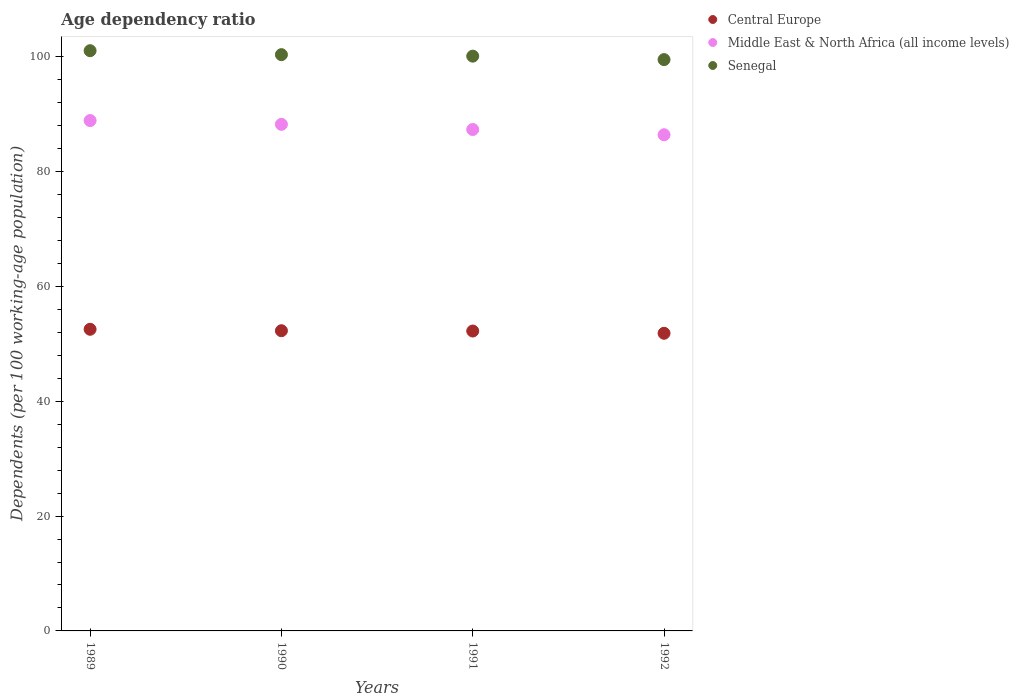What is the age dependency ratio in in Middle East & North Africa (all income levels) in 1991?
Make the answer very short. 87.33. Across all years, what is the maximum age dependency ratio in in Senegal?
Give a very brief answer. 101.06. Across all years, what is the minimum age dependency ratio in in Middle East & North Africa (all income levels)?
Offer a very short reply. 86.42. In which year was the age dependency ratio in in Central Europe maximum?
Make the answer very short. 1989. In which year was the age dependency ratio in in Central Europe minimum?
Your answer should be very brief. 1992. What is the total age dependency ratio in in Senegal in the graph?
Make the answer very short. 401.05. What is the difference between the age dependency ratio in in Middle East & North Africa (all income levels) in 1989 and that in 1991?
Keep it short and to the point. 1.56. What is the difference between the age dependency ratio in in Senegal in 1991 and the age dependency ratio in in Central Europe in 1992?
Your response must be concise. 48.27. What is the average age dependency ratio in in Senegal per year?
Make the answer very short. 100.26. In the year 1992, what is the difference between the age dependency ratio in in Senegal and age dependency ratio in in Middle East & North Africa (all income levels)?
Provide a succinct answer. 13.09. What is the ratio of the age dependency ratio in in Middle East & North Africa (all income levels) in 1990 to that in 1991?
Offer a terse response. 1.01. Is the difference between the age dependency ratio in in Senegal in 1989 and 1990 greater than the difference between the age dependency ratio in in Middle East & North Africa (all income levels) in 1989 and 1990?
Ensure brevity in your answer.  Yes. What is the difference between the highest and the second highest age dependency ratio in in Senegal?
Keep it short and to the point. 0.69. What is the difference between the highest and the lowest age dependency ratio in in Central Europe?
Offer a terse response. 0.7. In how many years, is the age dependency ratio in in Central Europe greater than the average age dependency ratio in in Central Europe taken over all years?
Provide a succinct answer. 3. Is the sum of the age dependency ratio in in Middle East & North Africa (all income levels) in 1989 and 1990 greater than the maximum age dependency ratio in in Central Europe across all years?
Offer a terse response. Yes. Is it the case that in every year, the sum of the age dependency ratio in in Middle East & North Africa (all income levels) and age dependency ratio in in Senegal  is greater than the age dependency ratio in in Central Europe?
Offer a terse response. Yes. Is the age dependency ratio in in Senegal strictly greater than the age dependency ratio in in Central Europe over the years?
Ensure brevity in your answer.  Yes. How many years are there in the graph?
Give a very brief answer. 4. Are the values on the major ticks of Y-axis written in scientific E-notation?
Ensure brevity in your answer.  No. Does the graph contain grids?
Provide a succinct answer. No. Where does the legend appear in the graph?
Your answer should be very brief. Top right. How many legend labels are there?
Your answer should be very brief. 3. How are the legend labels stacked?
Provide a short and direct response. Vertical. What is the title of the graph?
Ensure brevity in your answer.  Age dependency ratio. Does "Sri Lanka" appear as one of the legend labels in the graph?
Provide a short and direct response. No. What is the label or title of the Y-axis?
Your answer should be compact. Dependents (per 100 working-age population). What is the Dependents (per 100 working-age population) in Central Europe in 1989?
Offer a terse response. 52.54. What is the Dependents (per 100 working-age population) in Middle East & North Africa (all income levels) in 1989?
Make the answer very short. 88.89. What is the Dependents (per 100 working-age population) of Senegal in 1989?
Offer a terse response. 101.06. What is the Dependents (per 100 working-age population) of Central Europe in 1990?
Your answer should be very brief. 52.29. What is the Dependents (per 100 working-age population) in Middle East & North Africa (all income levels) in 1990?
Ensure brevity in your answer.  88.23. What is the Dependents (per 100 working-age population) of Senegal in 1990?
Your answer should be compact. 100.37. What is the Dependents (per 100 working-age population) in Central Europe in 1991?
Offer a very short reply. 52.24. What is the Dependents (per 100 working-age population) of Middle East & North Africa (all income levels) in 1991?
Offer a terse response. 87.33. What is the Dependents (per 100 working-age population) in Senegal in 1991?
Make the answer very short. 100.11. What is the Dependents (per 100 working-age population) of Central Europe in 1992?
Offer a very short reply. 51.84. What is the Dependents (per 100 working-age population) of Middle East & North Africa (all income levels) in 1992?
Your answer should be very brief. 86.42. What is the Dependents (per 100 working-age population) of Senegal in 1992?
Offer a very short reply. 99.51. Across all years, what is the maximum Dependents (per 100 working-age population) in Central Europe?
Give a very brief answer. 52.54. Across all years, what is the maximum Dependents (per 100 working-age population) of Middle East & North Africa (all income levels)?
Your answer should be very brief. 88.89. Across all years, what is the maximum Dependents (per 100 working-age population) in Senegal?
Your response must be concise. 101.06. Across all years, what is the minimum Dependents (per 100 working-age population) of Central Europe?
Provide a succinct answer. 51.84. Across all years, what is the minimum Dependents (per 100 working-age population) of Middle East & North Africa (all income levels)?
Offer a terse response. 86.42. Across all years, what is the minimum Dependents (per 100 working-age population) in Senegal?
Provide a short and direct response. 99.51. What is the total Dependents (per 100 working-age population) in Central Europe in the graph?
Make the answer very short. 208.91. What is the total Dependents (per 100 working-age population) of Middle East & North Africa (all income levels) in the graph?
Your answer should be compact. 350.88. What is the total Dependents (per 100 working-age population) in Senegal in the graph?
Keep it short and to the point. 401.05. What is the difference between the Dependents (per 100 working-age population) in Central Europe in 1989 and that in 1990?
Provide a succinct answer. 0.25. What is the difference between the Dependents (per 100 working-age population) of Middle East & North Africa (all income levels) in 1989 and that in 1990?
Give a very brief answer. 0.66. What is the difference between the Dependents (per 100 working-age population) in Senegal in 1989 and that in 1990?
Provide a succinct answer. 0.69. What is the difference between the Dependents (per 100 working-age population) in Central Europe in 1989 and that in 1991?
Keep it short and to the point. 0.3. What is the difference between the Dependents (per 100 working-age population) in Middle East & North Africa (all income levels) in 1989 and that in 1991?
Your answer should be very brief. 1.56. What is the difference between the Dependents (per 100 working-age population) in Senegal in 1989 and that in 1991?
Ensure brevity in your answer.  0.95. What is the difference between the Dependents (per 100 working-age population) in Central Europe in 1989 and that in 1992?
Give a very brief answer. 0.7. What is the difference between the Dependents (per 100 working-age population) of Middle East & North Africa (all income levels) in 1989 and that in 1992?
Give a very brief answer. 2.47. What is the difference between the Dependents (per 100 working-age population) in Senegal in 1989 and that in 1992?
Provide a succinct answer. 1.55. What is the difference between the Dependents (per 100 working-age population) in Central Europe in 1990 and that in 1991?
Keep it short and to the point. 0.05. What is the difference between the Dependents (per 100 working-age population) of Middle East & North Africa (all income levels) in 1990 and that in 1991?
Your answer should be compact. 0.9. What is the difference between the Dependents (per 100 working-age population) in Senegal in 1990 and that in 1991?
Keep it short and to the point. 0.26. What is the difference between the Dependents (per 100 working-age population) of Central Europe in 1990 and that in 1992?
Your response must be concise. 0.44. What is the difference between the Dependents (per 100 working-age population) of Middle East & North Africa (all income levels) in 1990 and that in 1992?
Make the answer very short. 1.81. What is the difference between the Dependents (per 100 working-age population) in Senegal in 1990 and that in 1992?
Provide a short and direct response. 0.86. What is the difference between the Dependents (per 100 working-age population) of Central Europe in 1991 and that in 1992?
Keep it short and to the point. 0.39. What is the difference between the Dependents (per 100 working-age population) in Middle East & North Africa (all income levels) in 1991 and that in 1992?
Provide a succinct answer. 0.91. What is the difference between the Dependents (per 100 working-age population) of Senegal in 1991 and that in 1992?
Your answer should be compact. 0.6. What is the difference between the Dependents (per 100 working-age population) of Central Europe in 1989 and the Dependents (per 100 working-age population) of Middle East & North Africa (all income levels) in 1990?
Your answer should be compact. -35.69. What is the difference between the Dependents (per 100 working-age population) of Central Europe in 1989 and the Dependents (per 100 working-age population) of Senegal in 1990?
Give a very brief answer. -47.83. What is the difference between the Dependents (per 100 working-age population) of Middle East & North Africa (all income levels) in 1989 and the Dependents (per 100 working-age population) of Senegal in 1990?
Provide a succinct answer. -11.48. What is the difference between the Dependents (per 100 working-age population) in Central Europe in 1989 and the Dependents (per 100 working-age population) in Middle East & North Africa (all income levels) in 1991?
Offer a very short reply. -34.79. What is the difference between the Dependents (per 100 working-age population) in Central Europe in 1989 and the Dependents (per 100 working-age population) in Senegal in 1991?
Make the answer very short. -47.57. What is the difference between the Dependents (per 100 working-age population) in Middle East & North Africa (all income levels) in 1989 and the Dependents (per 100 working-age population) in Senegal in 1991?
Keep it short and to the point. -11.22. What is the difference between the Dependents (per 100 working-age population) of Central Europe in 1989 and the Dependents (per 100 working-age population) of Middle East & North Africa (all income levels) in 1992?
Ensure brevity in your answer.  -33.88. What is the difference between the Dependents (per 100 working-age population) of Central Europe in 1989 and the Dependents (per 100 working-age population) of Senegal in 1992?
Offer a very short reply. -46.97. What is the difference between the Dependents (per 100 working-age population) of Middle East & North Africa (all income levels) in 1989 and the Dependents (per 100 working-age population) of Senegal in 1992?
Your answer should be compact. -10.62. What is the difference between the Dependents (per 100 working-age population) of Central Europe in 1990 and the Dependents (per 100 working-age population) of Middle East & North Africa (all income levels) in 1991?
Offer a terse response. -35.05. What is the difference between the Dependents (per 100 working-age population) of Central Europe in 1990 and the Dependents (per 100 working-age population) of Senegal in 1991?
Offer a terse response. -47.82. What is the difference between the Dependents (per 100 working-age population) of Middle East & North Africa (all income levels) in 1990 and the Dependents (per 100 working-age population) of Senegal in 1991?
Your answer should be very brief. -11.88. What is the difference between the Dependents (per 100 working-age population) of Central Europe in 1990 and the Dependents (per 100 working-age population) of Middle East & North Africa (all income levels) in 1992?
Make the answer very short. -34.13. What is the difference between the Dependents (per 100 working-age population) in Central Europe in 1990 and the Dependents (per 100 working-age population) in Senegal in 1992?
Ensure brevity in your answer.  -47.22. What is the difference between the Dependents (per 100 working-age population) of Middle East & North Africa (all income levels) in 1990 and the Dependents (per 100 working-age population) of Senegal in 1992?
Your answer should be very brief. -11.28. What is the difference between the Dependents (per 100 working-age population) of Central Europe in 1991 and the Dependents (per 100 working-age population) of Middle East & North Africa (all income levels) in 1992?
Provide a short and direct response. -34.19. What is the difference between the Dependents (per 100 working-age population) of Central Europe in 1991 and the Dependents (per 100 working-age population) of Senegal in 1992?
Keep it short and to the point. -47.27. What is the difference between the Dependents (per 100 working-age population) in Middle East & North Africa (all income levels) in 1991 and the Dependents (per 100 working-age population) in Senegal in 1992?
Offer a terse response. -12.18. What is the average Dependents (per 100 working-age population) of Central Europe per year?
Your response must be concise. 52.23. What is the average Dependents (per 100 working-age population) in Middle East & North Africa (all income levels) per year?
Make the answer very short. 87.72. What is the average Dependents (per 100 working-age population) of Senegal per year?
Your answer should be very brief. 100.26. In the year 1989, what is the difference between the Dependents (per 100 working-age population) in Central Europe and Dependents (per 100 working-age population) in Middle East & North Africa (all income levels)?
Your answer should be compact. -36.35. In the year 1989, what is the difference between the Dependents (per 100 working-age population) in Central Europe and Dependents (per 100 working-age population) in Senegal?
Offer a terse response. -48.52. In the year 1989, what is the difference between the Dependents (per 100 working-age population) in Middle East & North Africa (all income levels) and Dependents (per 100 working-age population) in Senegal?
Provide a short and direct response. -12.17. In the year 1990, what is the difference between the Dependents (per 100 working-age population) in Central Europe and Dependents (per 100 working-age population) in Middle East & North Africa (all income levels)?
Your response must be concise. -35.94. In the year 1990, what is the difference between the Dependents (per 100 working-age population) in Central Europe and Dependents (per 100 working-age population) in Senegal?
Give a very brief answer. -48.08. In the year 1990, what is the difference between the Dependents (per 100 working-age population) of Middle East & North Africa (all income levels) and Dependents (per 100 working-age population) of Senegal?
Offer a terse response. -12.14. In the year 1991, what is the difference between the Dependents (per 100 working-age population) of Central Europe and Dependents (per 100 working-age population) of Middle East & North Africa (all income levels)?
Your answer should be compact. -35.1. In the year 1991, what is the difference between the Dependents (per 100 working-age population) in Central Europe and Dependents (per 100 working-age population) in Senegal?
Your answer should be very brief. -47.88. In the year 1991, what is the difference between the Dependents (per 100 working-age population) of Middle East & North Africa (all income levels) and Dependents (per 100 working-age population) of Senegal?
Offer a terse response. -12.78. In the year 1992, what is the difference between the Dependents (per 100 working-age population) in Central Europe and Dependents (per 100 working-age population) in Middle East & North Africa (all income levels)?
Provide a short and direct response. -34.58. In the year 1992, what is the difference between the Dependents (per 100 working-age population) of Central Europe and Dependents (per 100 working-age population) of Senegal?
Offer a terse response. -47.67. In the year 1992, what is the difference between the Dependents (per 100 working-age population) in Middle East & North Africa (all income levels) and Dependents (per 100 working-age population) in Senegal?
Your answer should be very brief. -13.09. What is the ratio of the Dependents (per 100 working-age population) in Central Europe in 1989 to that in 1990?
Keep it short and to the point. 1. What is the ratio of the Dependents (per 100 working-age population) in Middle East & North Africa (all income levels) in 1989 to that in 1990?
Give a very brief answer. 1.01. What is the ratio of the Dependents (per 100 working-age population) of Senegal in 1989 to that in 1990?
Provide a short and direct response. 1.01. What is the ratio of the Dependents (per 100 working-age population) of Central Europe in 1989 to that in 1991?
Provide a succinct answer. 1.01. What is the ratio of the Dependents (per 100 working-age population) in Middle East & North Africa (all income levels) in 1989 to that in 1991?
Ensure brevity in your answer.  1.02. What is the ratio of the Dependents (per 100 working-age population) of Senegal in 1989 to that in 1991?
Provide a short and direct response. 1.01. What is the ratio of the Dependents (per 100 working-age population) in Central Europe in 1989 to that in 1992?
Keep it short and to the point. 1.01. What is the ratio of the Dependents (per 100 working-age population) of Middle East & North Africa (all income levels) in 1989 to that in 1992?
Provide a short and direct response. 1.03. What is the ratio of the Dependents (per 100 working-age population) in Senegal in 1989 to that in 1992?
Offer a terse response. 1.02. What is the ratio of the Dependents (per 100 working-age population) of Central Europe in 1990 to that in 1991?
Make the answer very short. 1. What is the ratio of the Dependents (per 100 working-age population) in Middle East & North Africa (all income levels) in 1990 to that in 1991?
Give a very brief answer. 1.01. What is the ratio of the Dependents (per 100 working-age population) in Senegal in 1990 to that in 1991?
Make the answer very short. 1. What is the ratio of the Dependents (per 100 working-age population) in Central Europe in 1990 to that in 1992?
Your answer should be compact. 1.01. What is the ratio of the Dependents (per 100 working-age population) of Middle East & North Africa (all income levels) in 1990 to that in 1992?
Your response must be concise. 1.02. What is the ratio of the Dependents (per 100 working-age population) of Senegal in 1990 to that in 1992?
Offer a terse response. 1.01. What is the ratio of the Dependents (per 100 working-age population) in Central Europe in 1991 to that in 1992?
Offer a very short reply. 1.01. What is the ratio of the Dependents (per 100 working-age population) of Middle East & North Africa (all income levels) in 1991 to that in 1992?
Your answer should be very brief. 1.01. What is the ratio of the Dependents (per 100 working-age population) of Senegal in 1991 to that in 1992?
Give a very brief answer. 1.01. What is the difference between the highest and the second highest Dependents (per 100 working-age population) in Central Europe?
Provide a short and direct response. 0.25. What is the difference between the highest and the second highest Dependents (per 100 working-age population) of Middle East & North Africa (all income levels)?
Your response must be concise. 0.66. What is the difference between the highest and the second highest Dependents (per 100 working-age population) in Senegal?
Give a very brief answer. 0.69. What is the difference between the highest and the lowest Dependents (per 100 working-age population) in Central Europe?
Make the answer very short. 0.7. What is the difference between the highest and the lowest Dependents (per 100 working-age population) in Middle East & North Africa (all income levels)?
Your response must be concise. 2.47. What is the difference between the highest and the lowest Dependents (per 100 working-age population) in Senegal?
Ensure brevity in your answer.  1.55. 